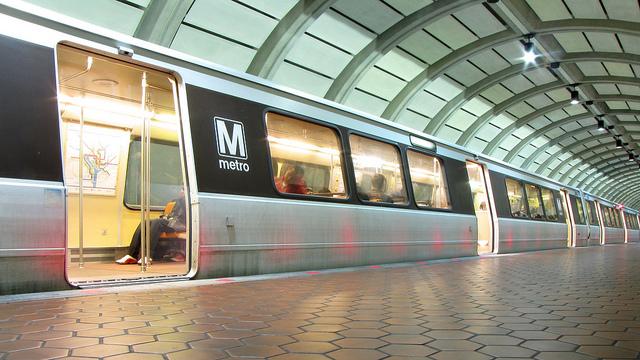What is the advertisement advertising?
Give a very brief answer. Metro. Is the train moving?
Answer briefly. No. Is this a color photo?
Be succinct. Yes. How many people in the shot?
Be succinct. 3. Is this a safe way to travel?
Short answer required. Yes. Where is the graffiti?
Short answer required. Nowhere. What is the word on the side of the train?
Quick response, please. Metro. 